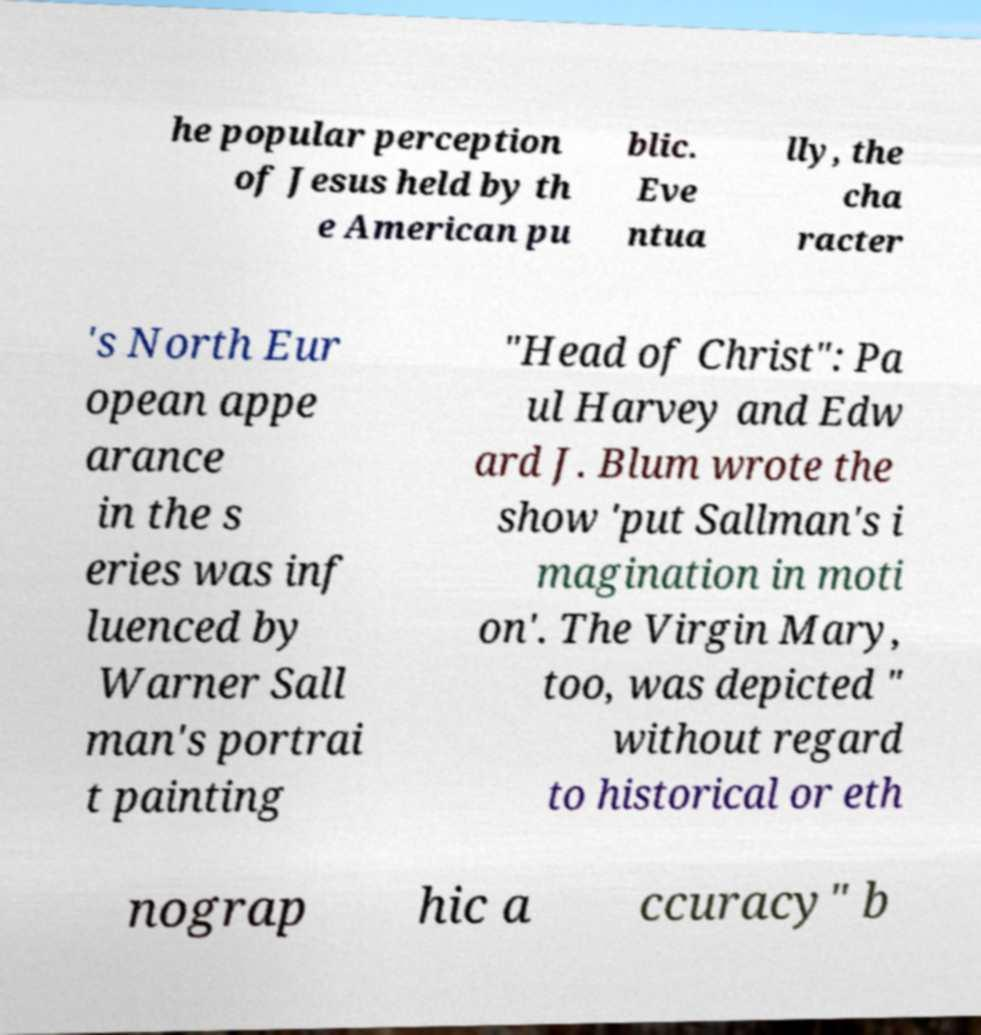For documentation purposes, I need the text within this image transcribed. Could you provide that? he popular perception of Jesus held by th e American pu blic. Eve ntua lly, the cha racter 's North Eur opean appe arance in the s eries was inf luenced by Warner Sall man's portrai t painting "Head of Christ": Pa ul Harvey and Edw ard J. Blum wrote the show 'put Sallman's i magination in moti on'. The Virgin Mary, too, was depicted " without regard to historical or eth nograp hic a ccuracy" b 